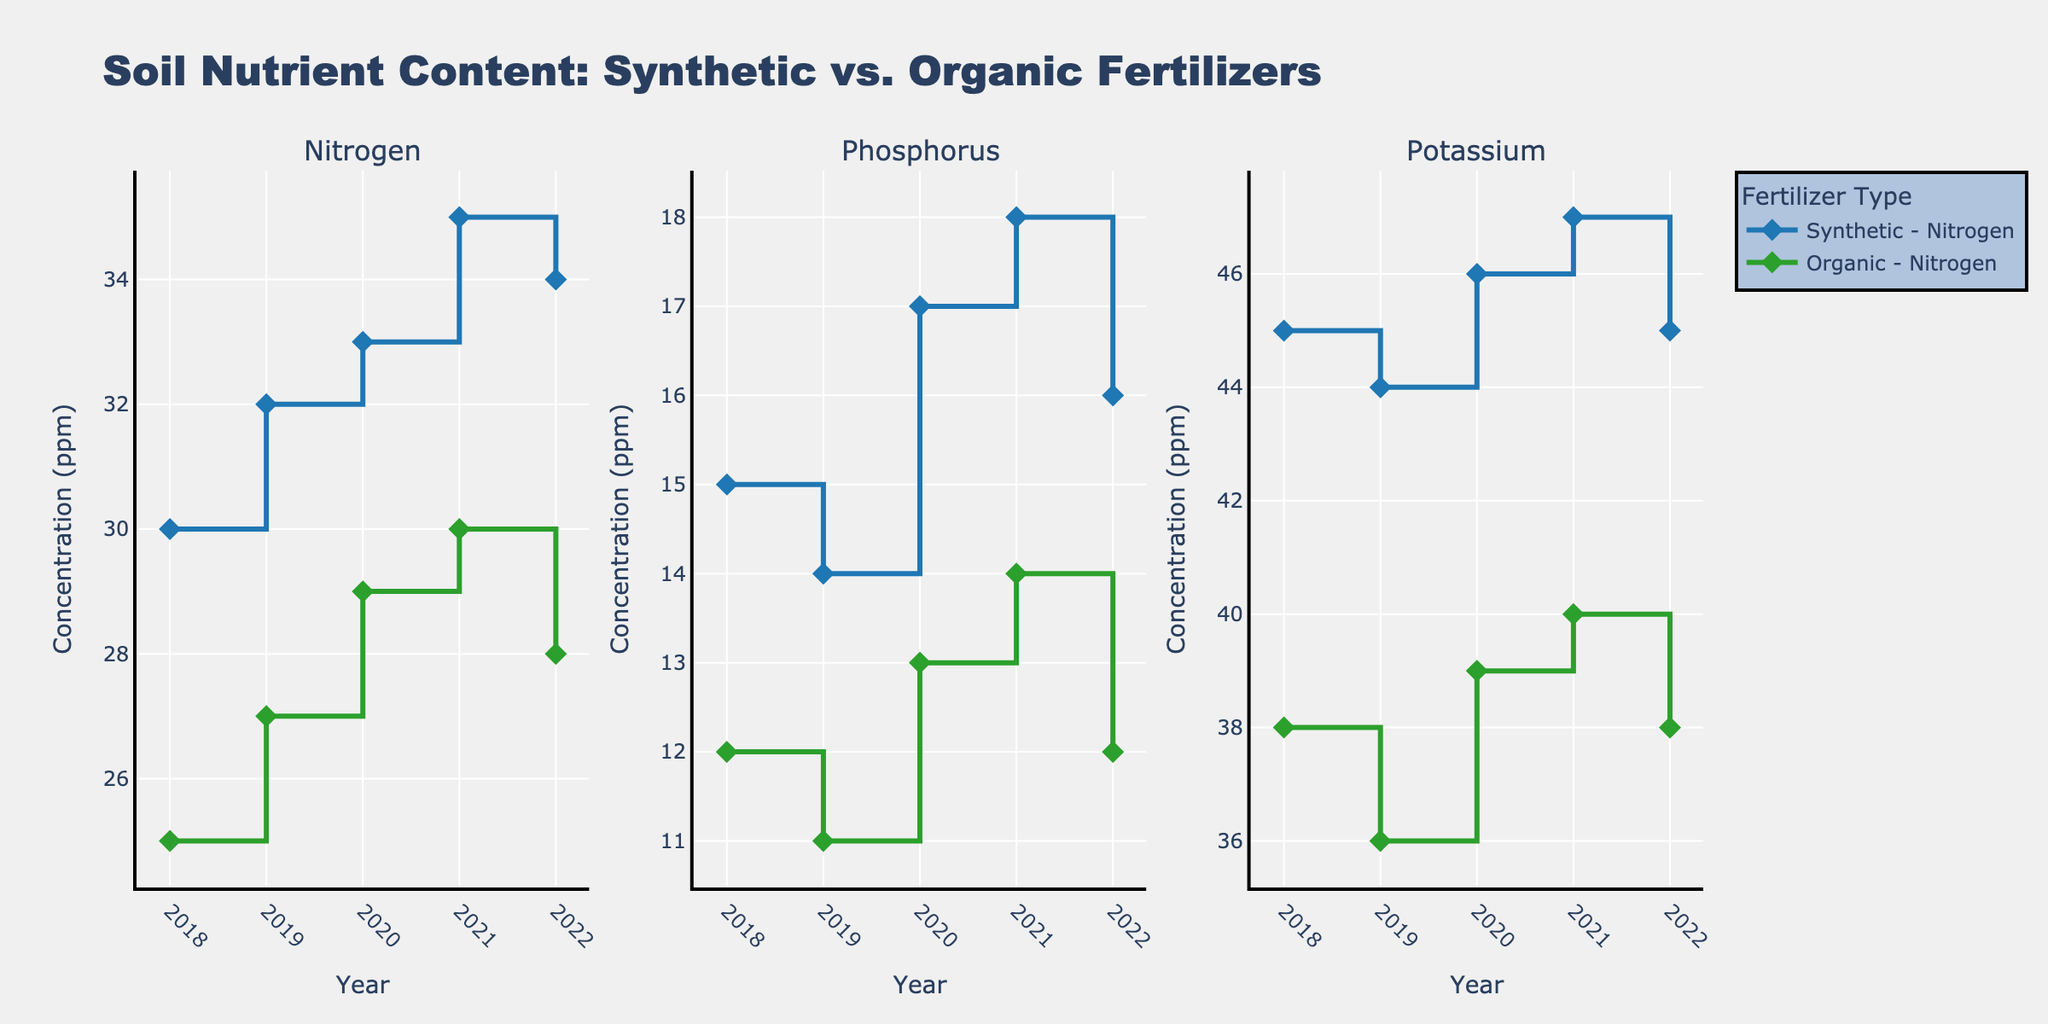What's the title of the figure? The title is prominently displayed at the top of the plot, which is easily observable.
Answer: Soil Nutrient Content: Synthetic vs. Organic Fertilizers How many nutrients are compared in the plot? The plot is divided into three subplots, each dedicated to a specific nutrient.
Answer: Three Which fertilizer generally shows higher Nitrogen content over the years? By observing the consistently higher values in the Synthetic-Fertilizers line compared to the Organic-Fertilizers line in the Nitrogen subplot, it is clear which one is higher.
Answer: Synthetic What is the Nitrogen content for Synthetic Fertilizers in 2021? Look at the intersection of the 2021 tick mark on the x-axis and the Nitrogen line for Synthetic Fertilizers.
Answer: 35 ppm Which year shows the highest Phosphorus level for Synthetic Fertilizers? Identify the peak in the Synthetic-Fertilizer line in the Phosphorus subplot and correlate it with the corresponding year.
Answer: 2021 Between which two years did the Organic Potassium content show the most significant increase? Look at the largest vertical step (increase) between consecutive years on the Organic Potassium line.
Answer: 2020 and 2021 Calculate the average Nitrogen content for Organic Fertilizers over the years displayed. Sum the Nitrogen values for Organic Fertilizers across all years and divide by the number of years: (25 + 27 + 29 + 30 + 28)/5.
Answer: 27.8 ppm Which nutrient shows the smallest difference in content between Synthetic and Organic Fertilizers in 2022? Compare the 2022 values of all nutrients for Synthetic and Organic Fertilizers and identify the smallest difference.
Answer: Phosphorus (4 ppm difference) How does the trend of Phosphorus content for Synthetic Fertilizers change from 2018 to 2022? Observe the slope and direction of changes in the Phosphorus line for Synthetic Fertilizers across the years.
Answer: Mostly increasing, with a dip in 2019 What's the general trend of Potassium content for both fertilizers from 2018 to 2022? Look at the overall changes in the Potassium lines for both Synthetic and Organic Fertilizers across the given years to identify the trend.
Answer: Generally stable with slight increases 